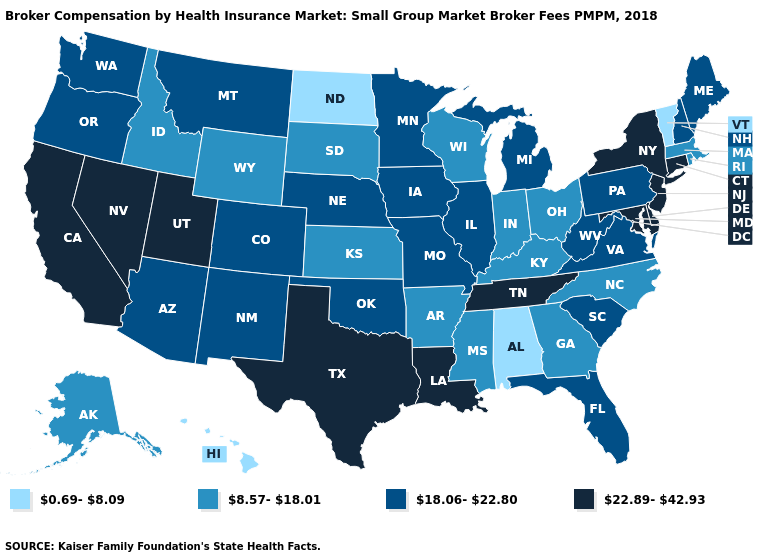What is the value of Utah?
Be succinct. 22.89-42.93. What is the lowest value in the USA?
Be succinct. 0.69-8.09. What is the highest value in the MidWest ?
Keep it brief. 18.06-22.80. Does Iowa have a higher value than Michigan?
Give a very brief answer. No. Among the states that border Florida , does Georgia have the highest value?
Keep it brief. Yes. Among the states that border Arkansas , which have the lowest value?
Quick response, please. Mississippi. Among the states that border Mississippi , does Alabama have the lowest value?
Give a very brief answer. Yes. Does the first symbol in the legend represent the smallest category?
Give a very brief answer. Yes. How many symbols are there in the legend?
Be succinct. 4. Which states hav the highest value in the Northeast?
Concise answer only. Connecticut, New Jersey, New York. What is the value of Louisiana?
Answer briefly. 22.89-42.93. Is the legend a continuous bar?
Concise answer only. No. What is the highest value in the USA?
Be succinct. 22.89-42.93. Name the states that have a value in the range 18.06-22.80?
Quick response, please. Arizona, Colorado, Florida, Illinois, Iowa, Maine, Michigan, Minnesota, Missouri, Montana, Nebraska, New Hampshire, New Mexico, Oklahoma, Oregon, Pennsylvania, South Carolina, Virginia, Washington, West Virginia. Does Tennessee have the highest value in the USA?
Keep it brief. Yes. 